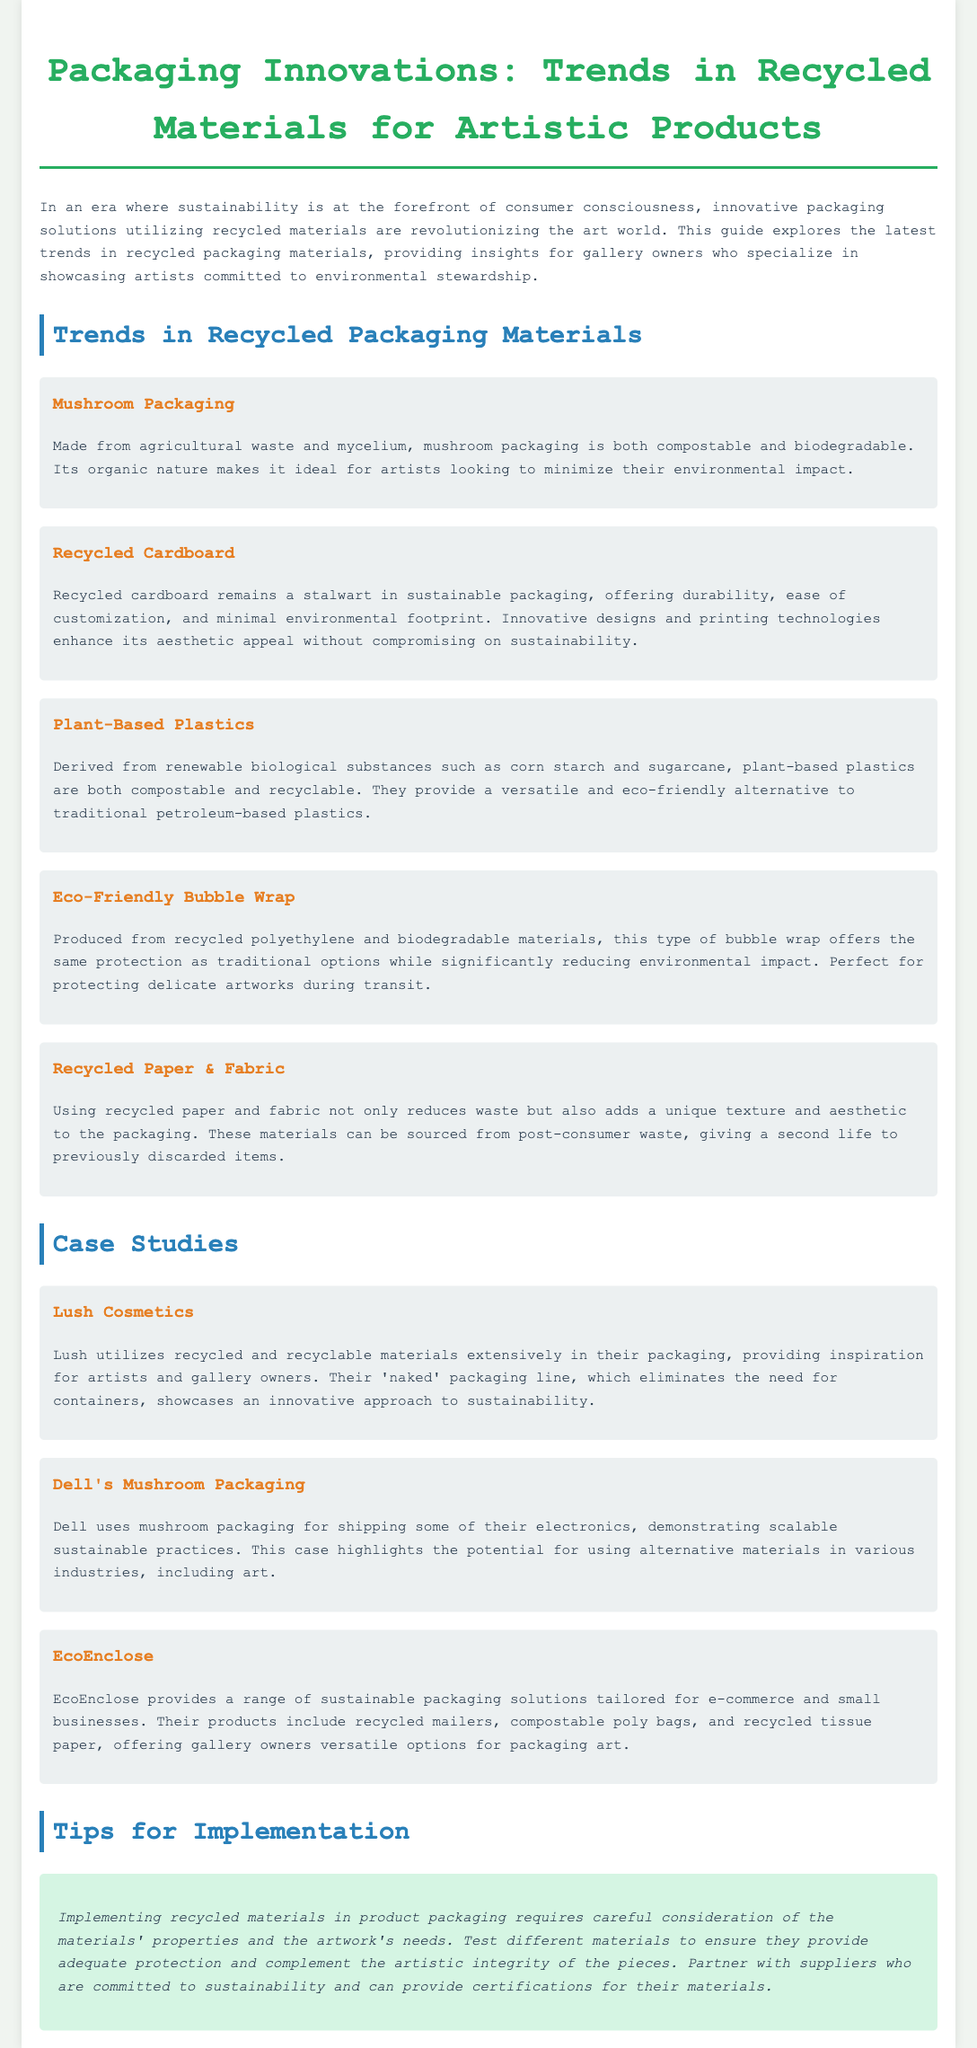What is mushroom packaging made from? Mushroom packaging is made from agricultural waste and mycelium.
Answer: agricultural waste and mycelium Which company uses mushroom packaging for shipping? Dell uses mushroom packaging for shipping some of their electronics.
Answer: Dell What type of plastic is derived from renewable biological substances? Plant-based plastics are derived from renewable biological substances.
Answer: Plant-based plastics What unique aspect do recycled paper and fabric add to packaging? Recycled paper and fabric add a unique texture and aesthetic to the packaging.
Answer: unique texture and aesthetic What is one significant approach taken by Lush for packaging? Lush's 'naked' packaging line eliminates the need for containers.
Answer: 'naked' packaging line How many case studies are mentioned in the document? There are three case studies mentioned in the document.
Answer: three What materials does EcoEnclose provide for packaging? EcoEnclose provides recycled mailers, compostable poly bags, and recycled tissue paper.
Answer: recycled mailers, compostable poly bags, and recycled tissue paper What main consideration is mentioned for implementing recycled materials? The main consideration is testing different materials to ensure they provide adequate protection.
Answer: testing different materials 